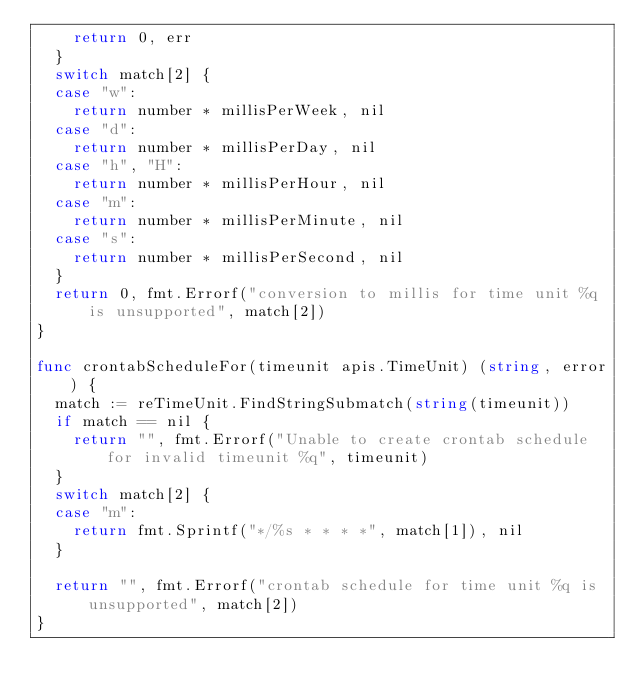Convert code to text. <code><loc_0><loc_0><loc_500><loc_500><_Go_>		return 0, err
	}
	switch match[2] {
	case "w":
		return number * millisPerWeek, nil
	case "d":
		return number * millisPerDay, nil
	case "h", "H":
		return number * millisPerHour, nil
	case "m":
		return number * millisPerMinute, nil
	case "s":
		return number * millisPerSecond, nil
	}
	return 0, fmt.Errorf("conversion to millis for time unit %q is unsupported", match[2])
}

func crontabScheduleFor(timeunit apis.TimeUnit) (string, error) {
	match := reTimeUnit.FindStringSubmatch(string(timeunit))
	if match == nil {
		return "", fmt.Errorf("Unable to create crontab schedule for invalid timeunit %q", timeunit)
	}
	switch match[2] {
	case "m":
		return fmt.Sprintf("*/%s * * * *", match[1]), nil
	}

	return "", fmt.Errorf("crontab schedule for time unit %q is unsupported", match[2])
}
</code> 